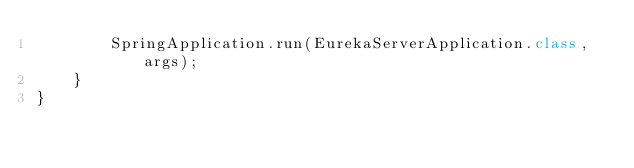Convert code to text. <code><loc_0><loc_0><loc_500><loc_500><_Java_>        SpringApplication.run(EurekaServerApplication.class, args);
    }
}
</code> 